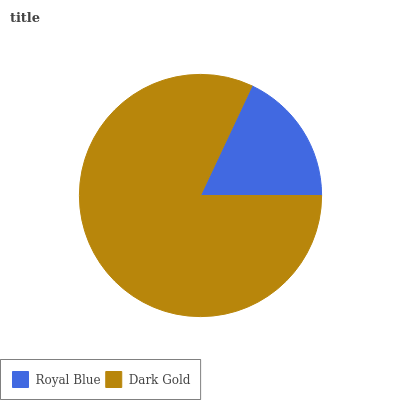Is Royal Blue the minimum?
Answer yes or no. Yes. Is Dark Gold the maximum?
Answer yes or no. Yes. Is Dark Gold the minimum?
Answer yes or no. No. Is Dark Gold greater than Royal Blue?
Answer yes or no. Yes. Is Royal Blue less than Dark Gold?
Answer yes or no. Yes. Is Royal Blue greater than Dark Gold?
Answer yes or no. No. Is Dark Gold less than Royal Blue?
Answer yes or no. No. Is Dark Gold the high median?
Answer yes or no. Yes. Is Royal Blue the low median?
Answer yes or no. Yes. Is Royal Blue the high median?
Answer yes or no. No. Is Dark Gold the low median?
Answer yes or no. No. 